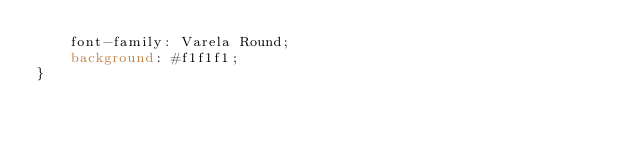<code> <loc_0><loc_0><loc_500><loc_500><_CSS_>    font-family: Varela Round;
    background: #f1f1f1;
}
</code> 